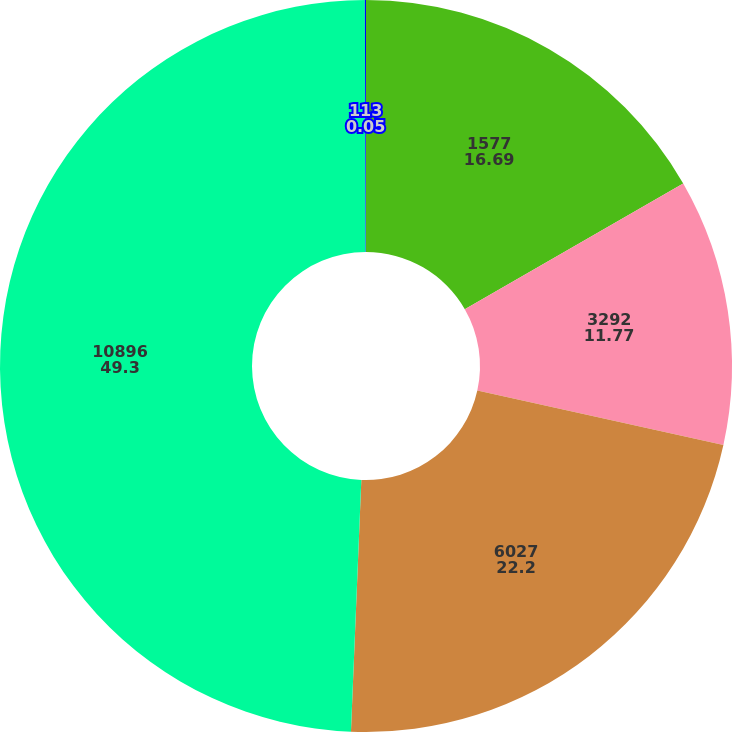Convert chart to OTSL. <chart><loc_0><loc_0><loc_500><loc_500><pie_chart><fcel>1577<fcel>3292<fcel>6027<fcel>10896<fcel>113<nl><fcel>16.69%<fcel>11.77%<fcel>22.2%<fcel>49.3%<fcel>0.05%<nl></chart> 